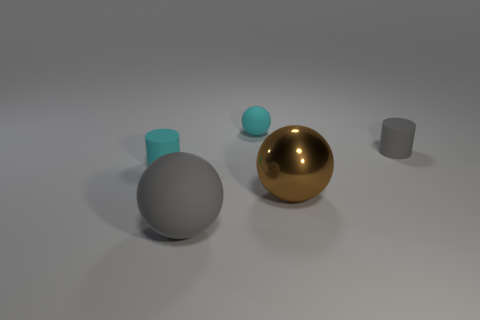Subtract all small cyan spheres. How many spheres are left? 2 Add 2 tiny red blocks. How many objects exist? 7 Subtract all cyan cylinders. How many cylinders are left? 1 Subtract all red cylinders. Subtract all green spheres. How many cylinders are left? 2 Add 1 gray matte objects. How many gray matte objects exist? 3 Subtract 1 gray cylinders. How many objects are left? 4 Subtract all cylinders. How many objects are left? 3 Subtract all rubber cylinders. Subtract all tiny cyan spheres. How many objects are left? 2 Add 2 brown balls. How many brown balls are left? 3 